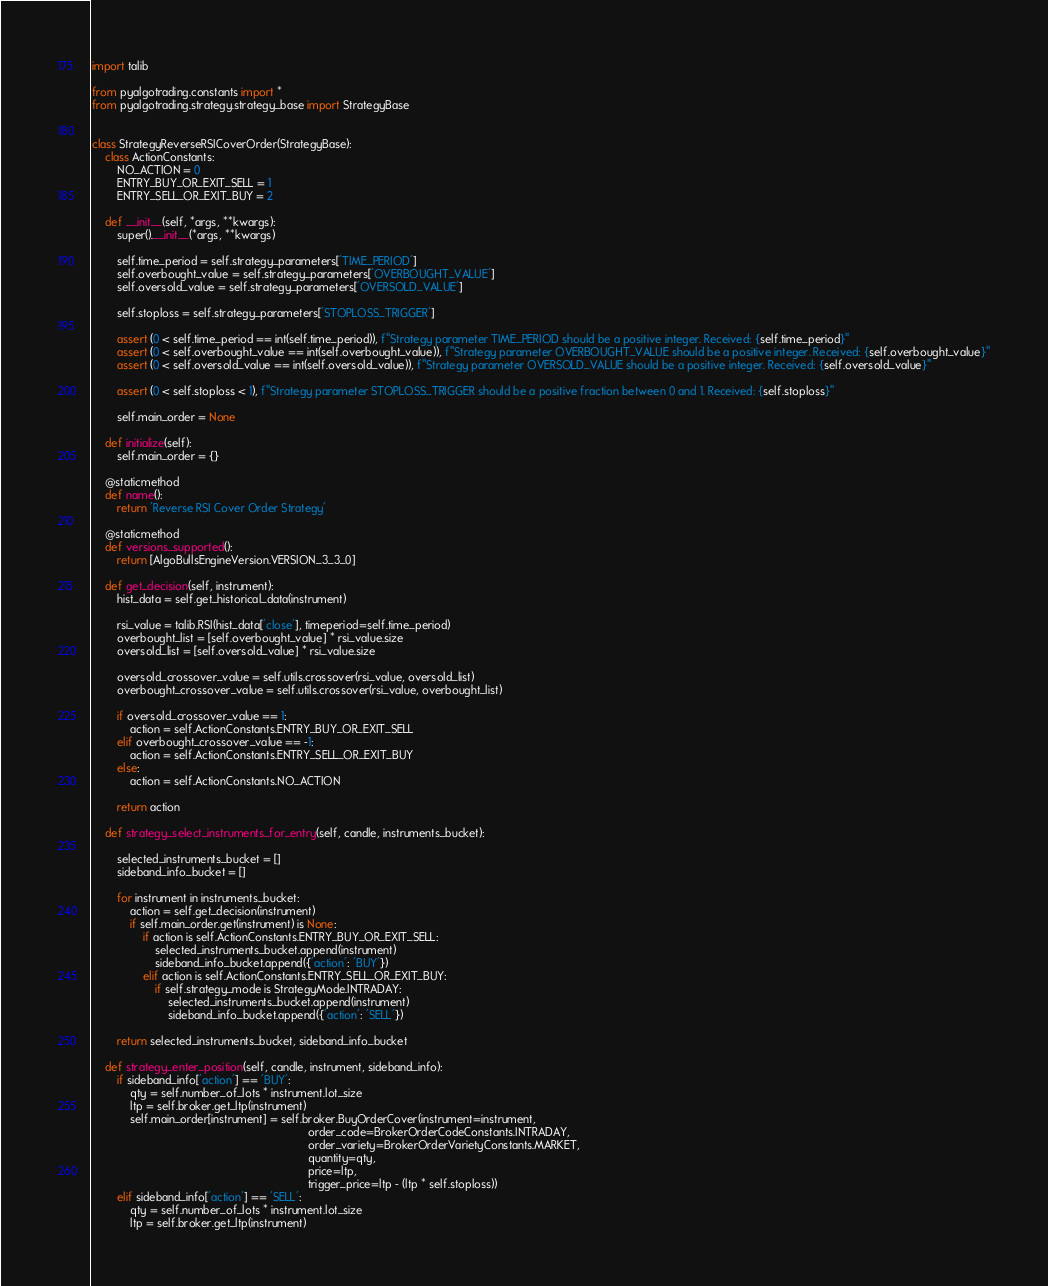Convert code to text. <code><loc_0><loc_0><loc_500><loc_500><_Python_>import talib

from pyalgotrading.constants import *
from pyalgotrading.strategy.strategy_base import StrategyBase


class StrategyReverseRSICoverOrder(StrategyBase):
    class ActionConstants:
        NO_ACTION = 0
        ENTRY_BUY_OR_EXIT_SELL = 1
        ENTRY_SELL_OR_EXIT_BUY = 2

    def __init__(self, *args, **kwargs):
        super().__init__(*args, **kwargs)

        self.time_period = self.strategy_parameters['TIME_PERIOD']
        self.overbought_value = self.strategy_parameters['OVERBOUGHT_VALUE']
        self.oversold_value = self.strategy_parameters['OVERSOLD_VALUE']

        self.stoploss = self.strategy_parameters['STOPLOSS_TRIGGER']

        assert (0 < self.time_period == int(self.time_period)), f"Strategy parameter TIME_PERIOD should be a positive integer. Received: {self.time_period}"
        assert (0 < self.overbought_value == int(self.overbought_value)), f"Strategy parameter OVERBOUGHT_VALUE should be a positive integer. Received: {self.overbought_value}"
        assert (0 < self.oversold_value == int(self.oversold_value)), f"Strategy parameter OVERSOLD_VALUE should be a positive integer. Received: {self.oversold_value}"

        assert (0 < self.stoploss < 1), f"Strategy parameter STOPLOSS_TRIGGER should be a positive fraction between 0 and 1. Received: {self.stoploss}"

        self.main_order = None

    def initialize(self):
        self.main_order = {}

    @staticmethod
    def name():
        return 'Reverse RSI Cover Order Strategy'

    @staticmethod
    def versions_supported():
        return [AlgoBullsEngineVersion.VERSION_3_3_0]

    def get_decision(self, instrument):
        hist_data = self.get_historical_data(instrument)

        rsi_value = talib.RSI(hist_data['close'], timeperiod=self.time_period)
        overbought_list = [self.overbought_value] * rsi_value.size
        oversold_list = [self.oversold_value] * rsi_value.size

        oversold_crossover_value = self.utils.crossover(rsi_value, oversold_list)
        overbought_crossover_value = self.utils.crossover(rsi_value, overbought_list)

        if oversold_crossover_value == 1:
            action = self.ActionConstants.ENTRY_BUY_OR_EXIT_SELL
        elif overbought_crossover_value == -1:
            action = self.ActionConstants.ENTRY_SELL_OR_EXIT_BUY
        else:
            action = self.ActionConstants.NO_ACTION

        return action

    def strategy_select_instruments_for_entry(self, candle, instruments_bucket):

        selected_instruments_bucket = []
        sideband_info_bucket = []

        for instrument in instruments_bucket:
            action = self.get_decision(instrument)
            if self.main_order.get(instrument) is None:
                if action is self.ActionConstants.ENTRY_BUY_OR_EXIT_SELL:
                    selected_instruments_bucket.append(instrument)
                    sideband_info_bucket.append({'action': 'BUY'})
                elif action is self.ActionConstants.ENTRY_SELL_OR_EXIT_BUY:
                    if self.strategy_mode is StrategyMode.INTRADAY:
                        selected_instruments_bucket.append(instrument)
                        sideband_info_bucket.append({'action': 'SELL'})

        return selected_instruments_bucket, sideband_info_bucket

    def strategy_enter_position(self, candle, instrument, sideband_info):
        if sideband_info['action'] == 'BUY':
            qty = self.number_of_lots * instrument.lot_size
            ltp = self.broker.get_ltp(instrument)
            self.main_order[instrument] = self.broker.BuyOrderCover(instrument=instrument,
                                                                    order_code=BrokerOrderCodeConstants.INTRADAY,
                                                                    order_variety=BrokerOrderVarietyConstants.MARKET,
                                                                    quantity=qty,
                                                                    price=ltp,
                                                                    trigger_price=ltp - (ltp * self.stoploss))
        elif sideband_info['action'] == 'SELL':
            qty = self.number_of_lots * instrument.lot_size
            ltp = self.broker.get_ltp(instrument)</code> 